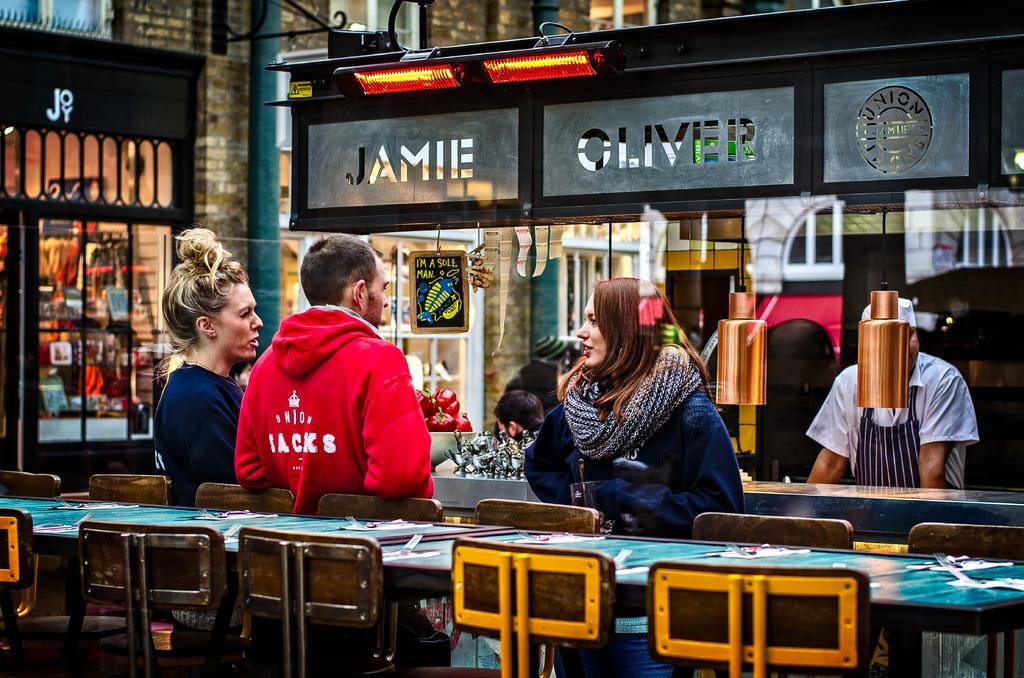Could you give a brief overview of what you see in this image? There are group of persons on the image ,three people are discussing between them and at the right side of the image there is a chef and at the top of the image there are two red color lights beneath that there are two glasses on which it is written as Jamie and Oliver union and at the left side of image there is a showroom called joy and at the middle of the image there is a board called I'm a sole man and red color jacket man leaning on these chairs 